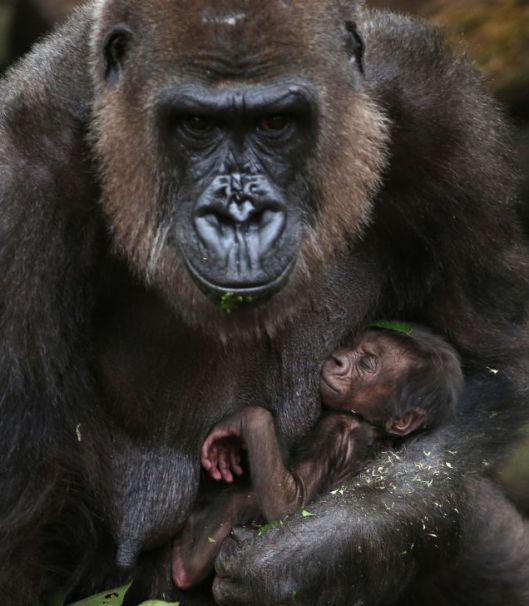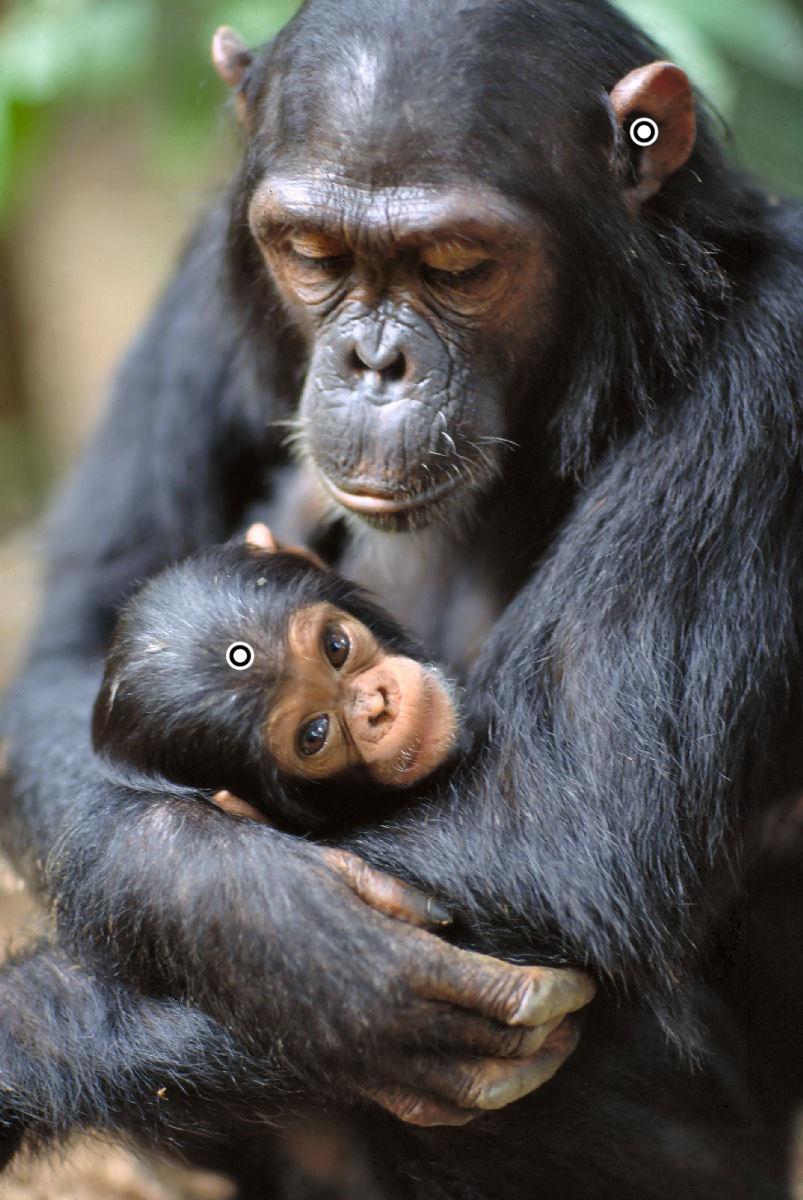The first image is the image on the left, the second image is the image on the right. For the images shown, is this caption "There are fewer than five chimpanzees in total." true? Answer yes or no. Yes. The first image is the image on the left, the second image is the image on the right. For the images displayed, is the sentence "Each image includes a baby ape in front of an adult ape." factually correct? Answer yes or no. Yes. 